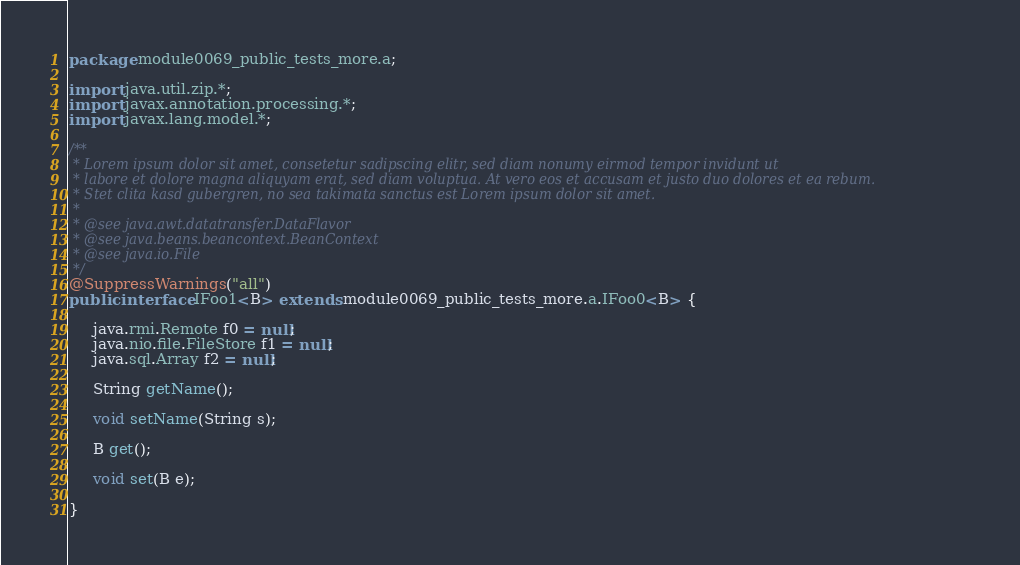<code> <loc_0><loc_0><loc_500><loc_500><_Java_>package module0069_public_tests_more.a;

import java.util.zip.*;
import javax.annotation.processing.*;
import javax.lang.model.*;

/**
 * Lorem ipsum dolor sit amet, consetetur sadipscing elitr, sed diam nonumy eirmod tempor invidunt ut 
 * labore et dolore magna aliquyam erat, sed diam voluptua. At vero eos et accusam et justo duo dolores et ea rebum. 
 * Stet clita kasd gubergren, no sea takimata sanctus est Lorem ipsum dolor sit amet. 
 *
 * @see java.awt.datatransfer.DataFlavor
 * @see java.beans.beancontext.BeanContext
 * @see java.io.File
 */
@SuppressWarnings("all")
public interface IFoo1<B> extends module0069_public_tests_more.a.IFoo0<B> {

	 java.rmi.Remote f0 = null;
	 java.nio.file.FileStore f1 = null;
	 java.sql.Array f2 = null;

	 String getName();

	 void setName(String s);

	 B get();

	 void set(B e);

}
</code> 